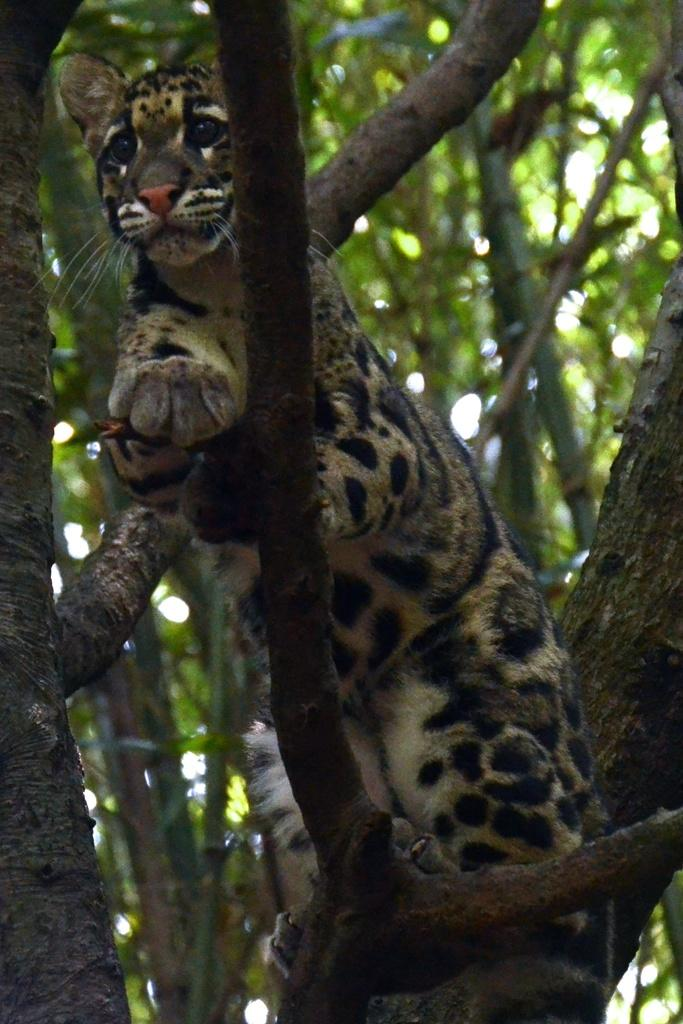What is the main subject of the image? There is an animal in the image. Where is the animal located? The animal is on a branch of a tree. Can you describe the possible setting of the image? The image may have been taken in a forest. How many writers are present in the image? There are no writers present in the image; it features an animal on a tree branch. What type of spy equipment can be seen in the image? There is no spy equipment present in the image; it features an animal on a tree branch. 